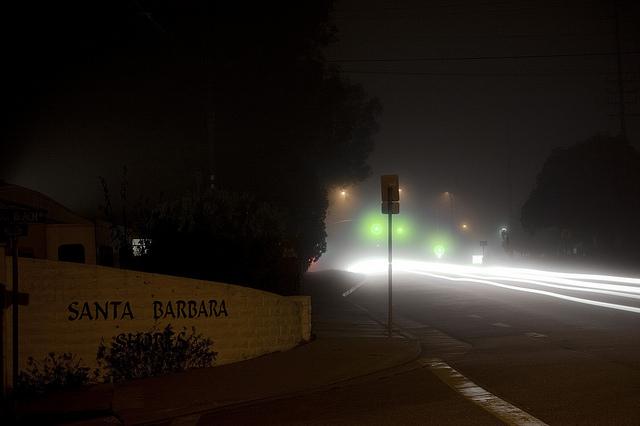What town is this?
Be succinct. Santa barbara. What city is this photo in?
Answer briefly. Santa barbara. Is someone on the street?
Write a very short answer. No. Is the photographer a fan of cat behavior?
Answer briefly. No. What is dangerous about driving here now?
Short answer required. Fog. What is the stoplight signaling?
Quick response, please. Go. Is this photo taken indoors?
Write a very short answer. No. Was this taken at night?
Quick response, please. Yes. Are there any people in this picture?
Answer briefly. No. 